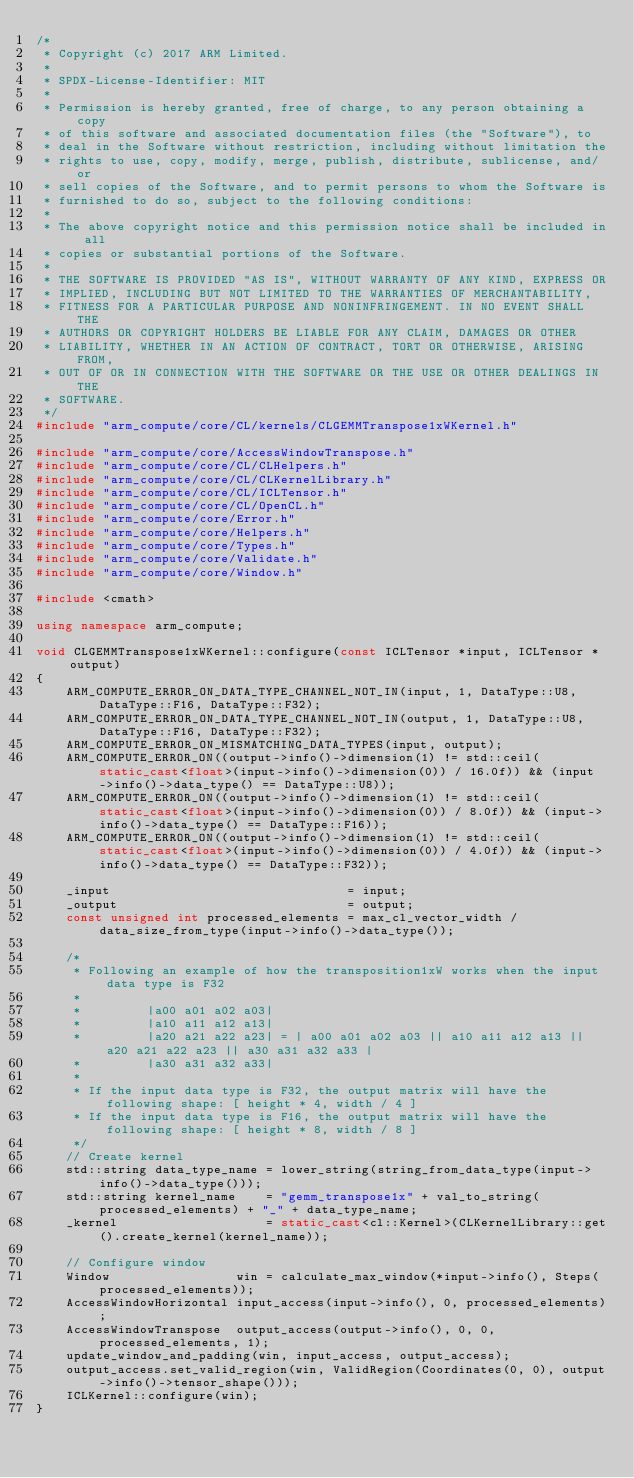Convert code to text. <code><loc_0><loc_0><loc_500><loc_500><_C++_>/*
 * Copyright (c) 2017 ARM Limited.
 *
 * SPDX-License-Identifier: MIT
 *
 * Permission is hereby granted, free of charge, to any person obtaining a copy
 * of this software and associated documentation files (the "Software"), to
 * deal in the Software without restriction, including without limitation the
 * rights to use, copy, modify, merge, publish, distribute, sublicense, and/or
 * sell copies of the Software, and to permit persons to whom the Software is
 * furnished to do so, subject to the following conditions:
 *
 * The above copyright notice and this permission notice shall be included in all
 * copies or substantial portions of the Software.
 *
 * THE SOFTWARE IS PROVIDED "AS IS", WITHOUT WARRANTY OF ANY KIND, EXPRESS OR
 * IMPLIED, INCLUDING BUT NOT LIMITED TO THE WARRANTIES OF MERCHANTABILITY,
 * FITNESS FOR A PARTICULAR PURPOSE AND NONINFRINGEMENT. IN NO EVENT SHALL THE
 * AUTHORS OR COPYRIGHT HOLDERS BE LIABLE FOR ANY CLAIM, DAMAGES OR OTHER
 * LIABILITY, WHETHER IN AN ACTION OF CONTRACT, TORT OR OTHERWISE, ARISING FROM,
 * OUT OF OR IN CONNECTION WITH THE SOFTWARE OR THE USE OR OTHER DEALINGS IN THE
 * SOFTWARE.
 */
#include "arm_compute/core/CL/kernels/CLGEMMTranspose1xWKernel.h"

#include "arm_compute/core/AccessWindowTranspose.h"
#include "arm_compute/core/CL/CLHelpers.h"
#include "arm_compute/core/CL/CLKernelLibrary.h"
#include "arm_compute/core/CL/ICLTensor.h"
#include "arm_compute/core/CL/OpenCL.h"
#include "arm_compute/core/Error.h"
#include "arm_compute/core/Helpers.h"
#include "arm_compute/core/Types.h"
#include "arm_compute/core/Validate.h"
#include "arm_compute/core/Window.h"

#include <cmath>

using namespace arm_compute;

void CLGEMMTranspose1xWKernel::configure(const ICLTensor *input, ICLTensor *output)
{
    ARM_COMPUTE_ERROR_ON_DATA_TYPE_CHANNEL_NOT_IN(input, 1, DataType::U8, DataType::F16, DataType::F32);
    ARM_COMPUTE_ERROR_ON_DATA_TYPE_CHANNEL_NOT_IN(output, 1, DataType::U8, DataType::F16, DataType::F32);
    ARM_COMPUTE_ERROR_ON_MISMATCHING_DATA_TYPES(input, output);
    ARM_COMPUTE_ERROR_ON((output->info()->dimension(1) != std::ceil(static_cast<float>(input->info()->dimension(0)) / 16.0f)) && (input->info()->data_type() == DataType::U8));
    ARM_COMPUTE_ERROR_ON((output->info()->dimension(1) != std::ceil(static_cast<float>(input->info()->dimension(0)) / 8.0f)) && (input->info()->data_type() == DataType::F16));
    ARM_COMPUTE_ERROR_ON((output->info()->dimension(1) != std::ceil(static_cast<float>(input->info()->dimension(0)) / 4.0f)) && (input->info()->data_type() == DataType::F32));

    _input                                = input;
    _output                               = output;
    const unsigned int processed_elements = max_cl_vector_width / data_size_from_type(input->info()->data_type());

    /*
     * Following an example of how the transposition1xW works when the input data type is F32
     *
     *         |a00 a01 a02 a03|
     *         |a10 a11 a12 a13|
     *         |a20 a21 a22 a23| = | a00 a01 a02 a03 || a10 a11 a12 a13 || a20 a21 a22 a23 || a30 a31 a32 a33 |
     *         |a30 a31 a32 a33|
     *
     * If the input data type is F32, the output matrix will have the following shape: [ height * 4, width / 4 ]
     * If the input data type is F16, the output matrix will have the following shape: [ height * 8, width / 8 ]
     */
    // Create kernel
    std::string data_type_name = lower_string(string_from_data_type(input->info()->data_type()));
    std::string kernel_name    = "gemm_transpose1x" + val_to_string(processed_elements) + "_" + data_type_name;
    _kernel                    = static_cast<cl::Kernel>(CLKernelLibrary::get().create_kernel(kernel_name));

    // Configure window
    Window                 win = calculate_max_window(*input->info(), Steps(processed_elements));
    AccessWindowHorizontal input_access(input->info(), 0, processed_elements);
    AccessWindowTranspose  output_access(output->info(), 0, 0, processed_elements, 1);
    update_window_and_padding(win, input_access, output_access);
    output_access.set_valid_region(win, ValidRegion(Coordinates(0, 0), output->info()->tensor_shape()));
    ICLKernel::configure(win);
}
</code> 